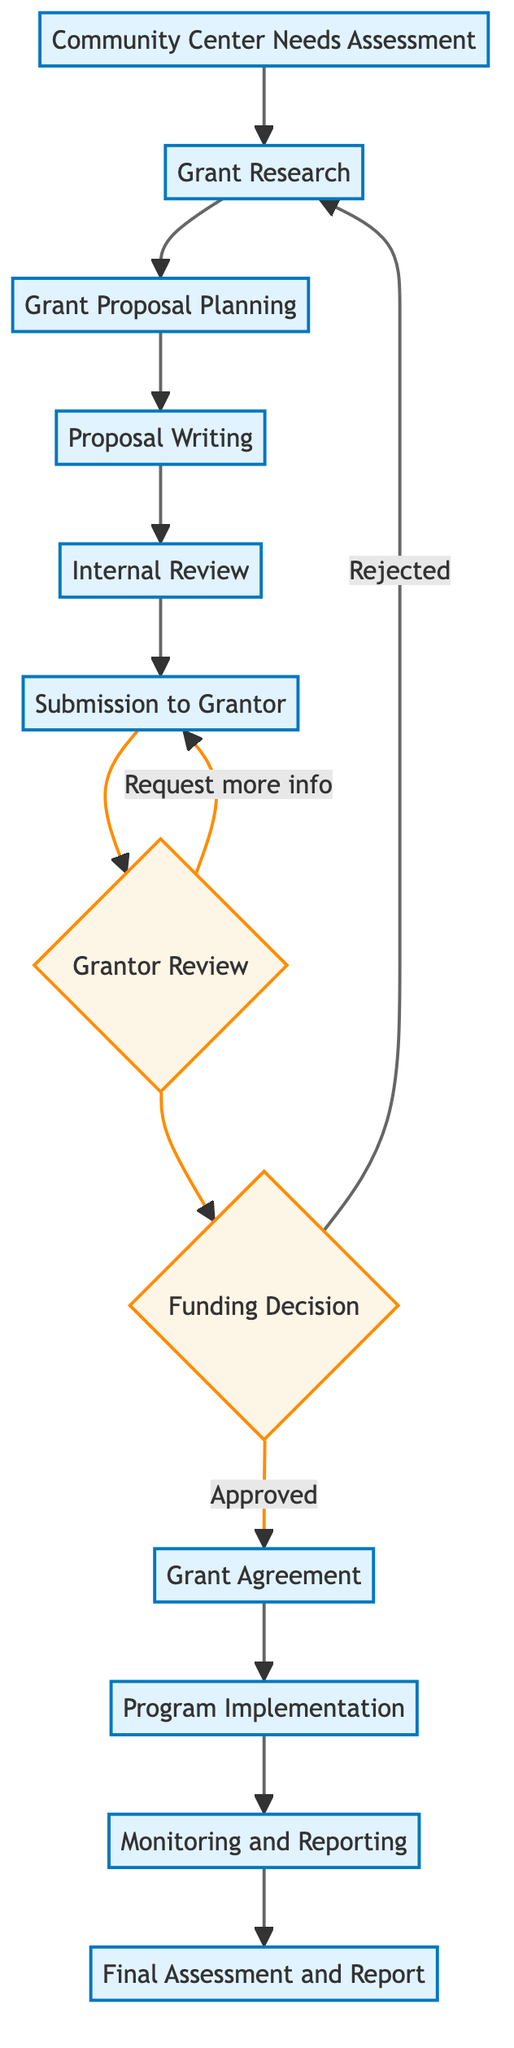What is the first step in the grant application process? The first step is "Community Center Needs Assessment," which involves identifying and documenting the cultural program needs of the community.
Answer: Community Center Needs Assessment How many nodes are there in the diagram? The diagram features a total of 12 distinct nodes connected by arrows that represent various stages and decisions in the grant application process.
Answer: 12 What happens if the funding decision is "Rejected"? If the grant proposal is rejected, the process loops back to "Grant Research," indicating the need to explore alternative funding opportunities after a rejection.
Answer: Grant Research Which step comes immediately after "Internal Review"? The step that follows "Internal Review" is "Submission to Grantor," where the finalized proposal is submitted to the funding organization.
Answer: Submission to Grantor What are the final two steps after "Program Implementation"? The last two steps following "Program Implementation" are "Monitoring and Reporting," and "Final Assessment and Report," which involve tracking progress and providing reports to the funder.
Answer: Monitoring and Reporting, Final Assessment and Report What is required if the funding decision is "Approved"? If the funding decision is approved, the next step is to sign the "Grant Agreement," which outlines the terms and conditions of the funding.
Answer: Grant Agreement Which step includes drafting the grant proposal? The step dedicated to drafting the grant proposal is "Proposal Writing," where various components like project narrative and budget justification are created.
Answer: Proposal Writing What do we do if additional information is requested during "Grantor Review"? If additional information is needed, the process loops back to "Submission to Grantor," indicating the requirement to provide the necessary details before moving forward.
Answer: Submission to Grantor What is the outcome of the "Grantor Review" decision process? The outcome includes two potential paths: either a "Funding Decision" is made (approved or rejected), or a request for more information can be made, requiring return to the proposal submission stage.
Answer: Funding Decision 